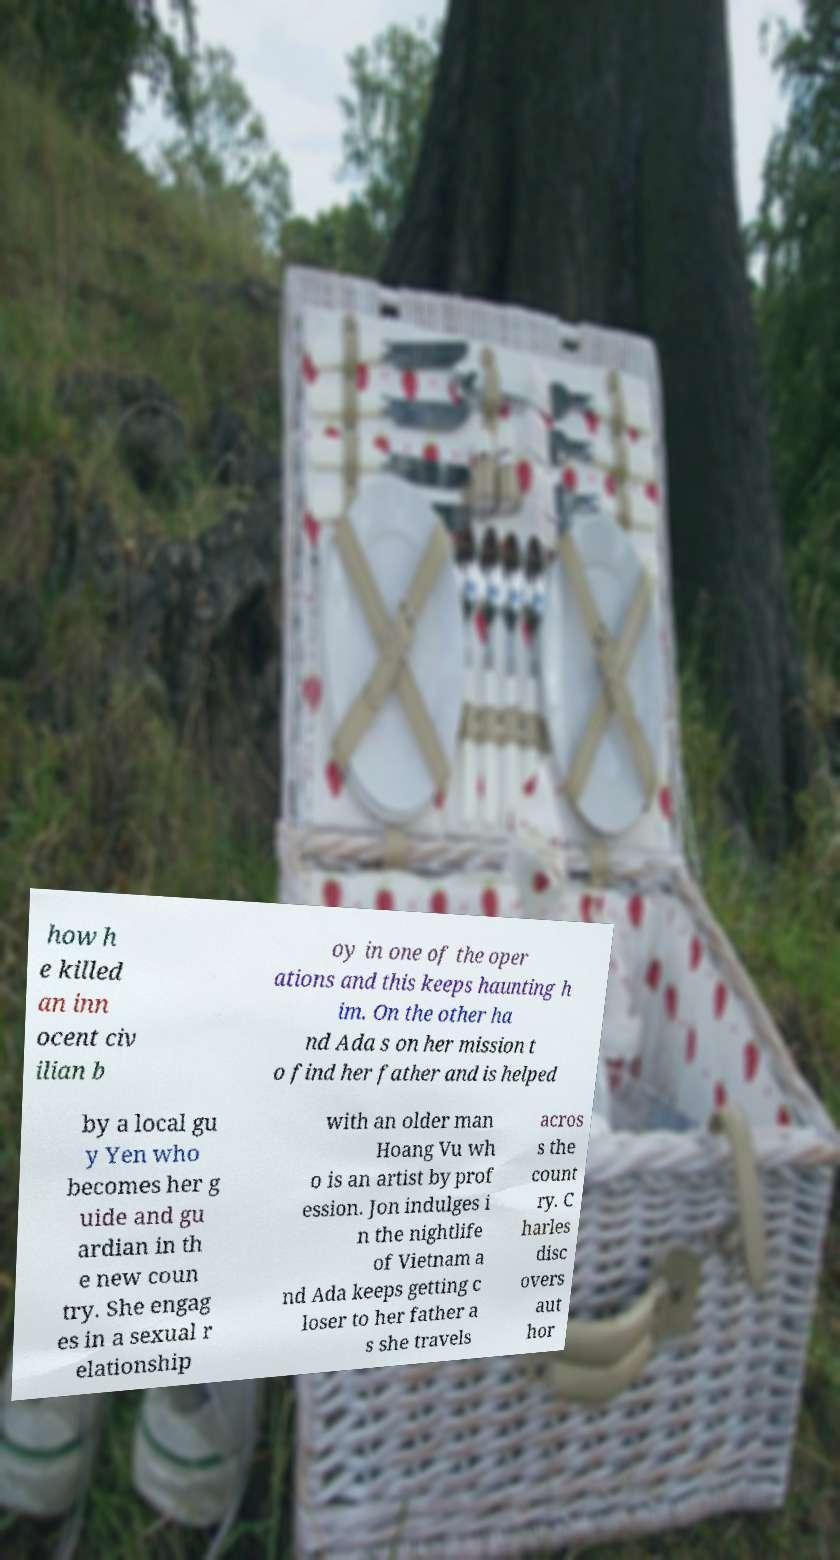Can you accurately transcribe the text from the provided image for me? how h e killed an inn ocent civ ilian b oy in one of the oper ations and this keeps haunting h im. On the other ha nd Ada s on her mission t o find her father and is helped by a local gu y Yen who becomes her g uide and gu ardian in th e new coun try. She engag es in a sexual r elationship with an older man Hoang Vu wh o is an artist by prof ession. Jon indulges i n the nightlife of Vietnam a nd Ada keeps getting c loser to her father a s she travels acros s the count ry. C harles disc overs aut hor 